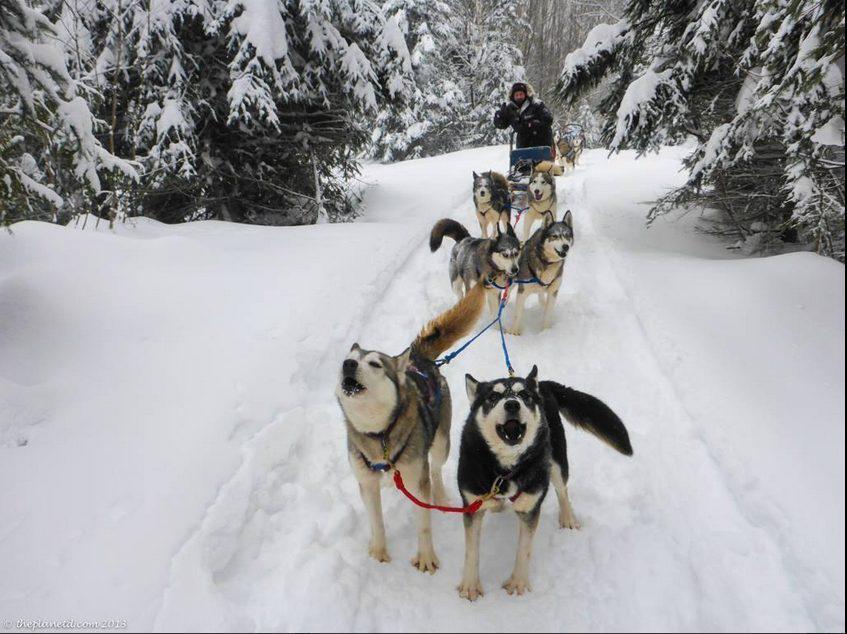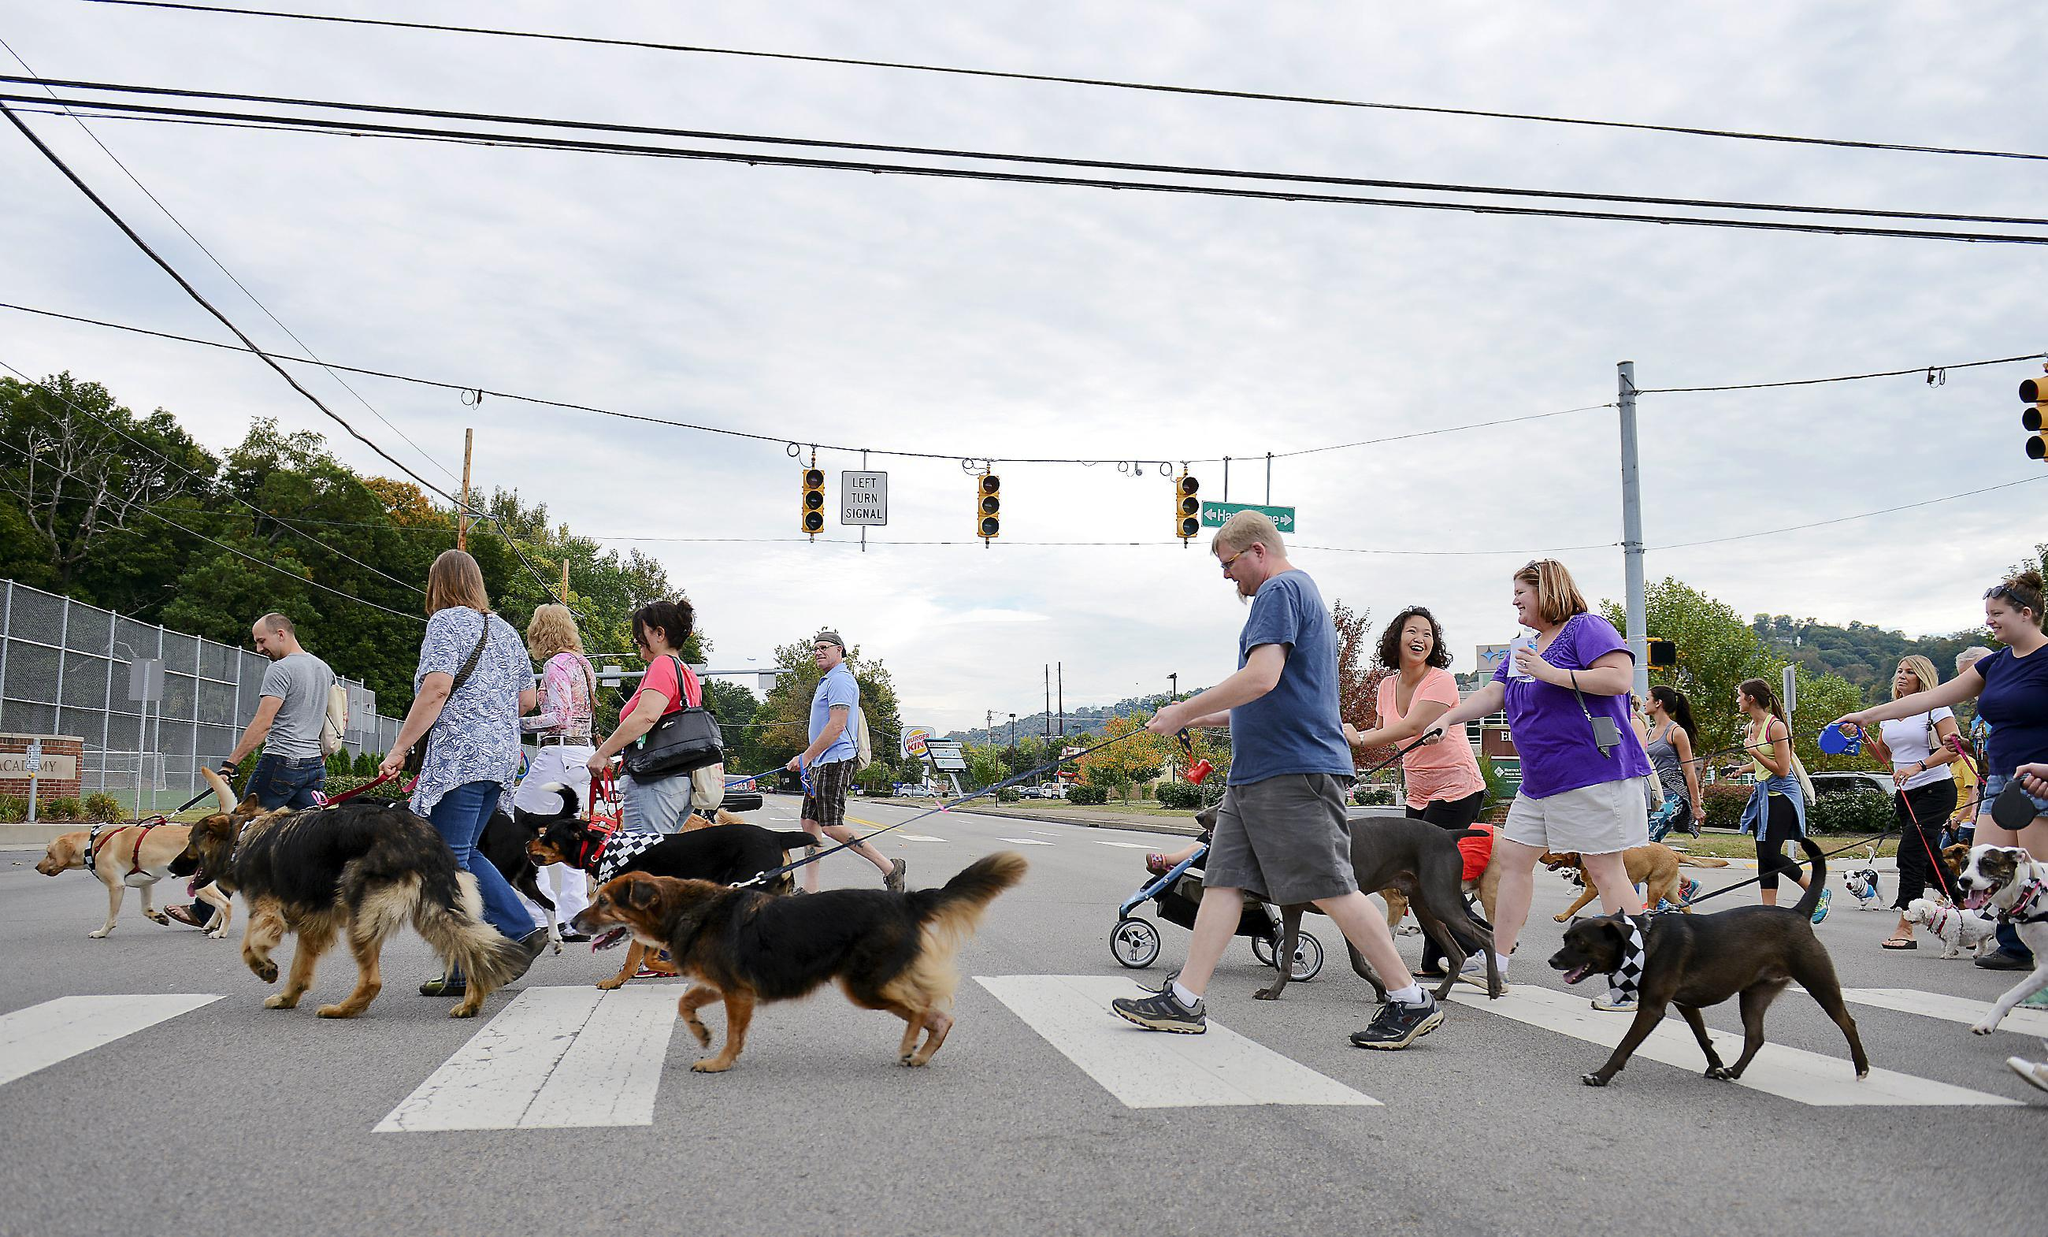The first image is the image on the left, the second image is the image on the right. For the images displayed, is the sentence "There are at least two people riding on one of the dog sleds." factually correct? Answer yes or no. No. The first image is the image on the left, the second image is the image on the right. Assess this claim about the two images: "the right image has humans in red jackets". Correct or not? Answer yes or no. No. 